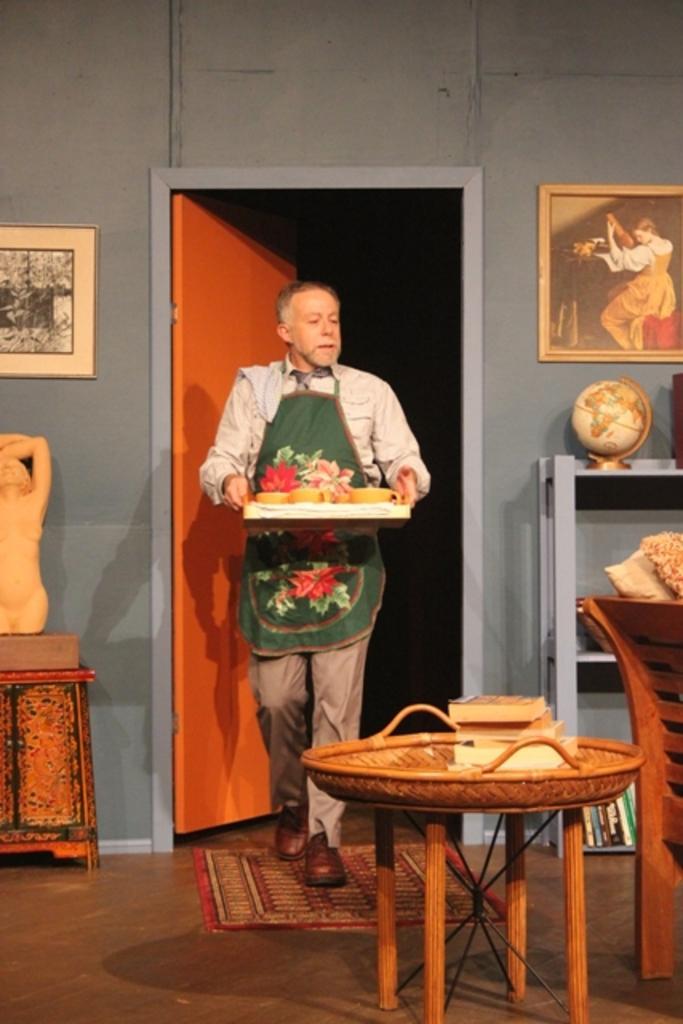How would you summarize this image in a sentence or two? As we can see in the image, there is a wall,photo frame, door and a man holding tray and on the right side there is a globe and chair. 